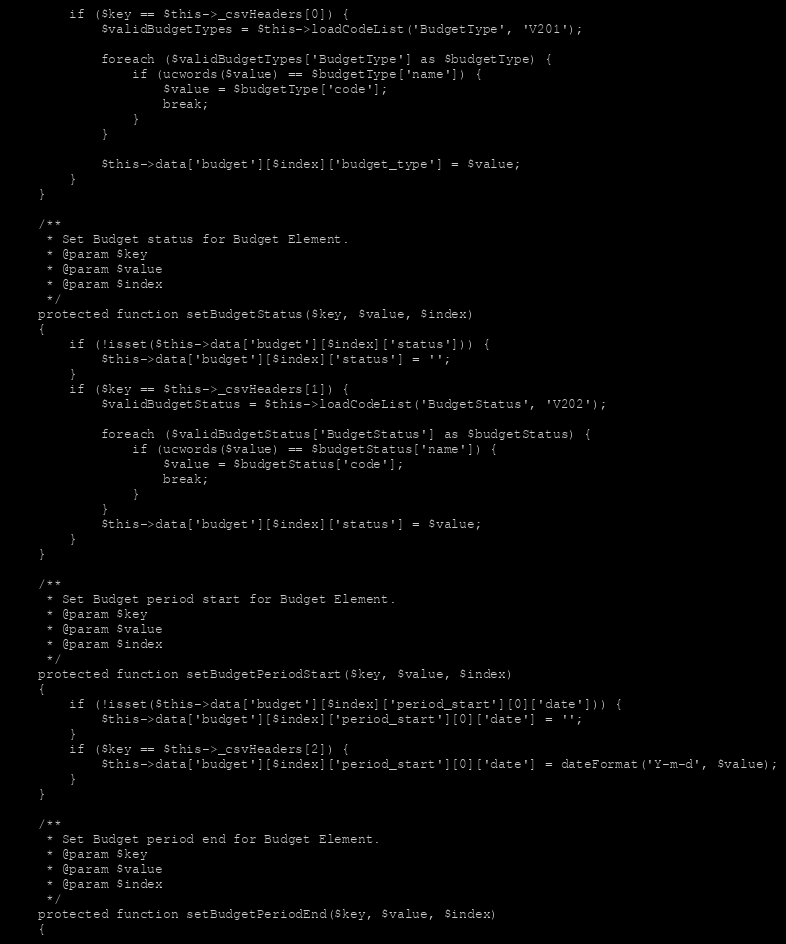Convert code to text. <code><loc_0><loc_0><loc_500><loc_500><_PHP_>        if ($key == $this->_csvHeaders[0]) {
            $validBudgetTypes = $this->loadCodeList('BudgetType', 'V201');

            foreach ($validBudgetTypes['BudgetType'] as $budgetType) {
                if (ucwords($value) == $budgetType['name']) {
                    $value = $budgetType['code'];
                    break;
                }
            }

            $this->data['budget'][$index]['budget_type'] = $value;
        }
    }

    /**
     * Set Budget status for Budget Element.
     * @param $key
     * @param $value
     * @param $index
     */
    protected function setBudgetStatus($key, $value, $index)
    {
        if (!isset($this->data['budget'][$index]['status'])) {
            $this->data['budget'][$index]['status'] = '';
        }
        if ($key == $this->_csvHeaders[1]) {
            $validBudgetStatus = $this->loadCodeList('BudgetStatus', 'V202');

            foreach ($validBudgetStatus['BudgetStatus'] as $budgetStatus) {
                if (ucwords($value) == $budgetStatus['name']) {
                    $value = $budgetStatus['code'];
                    break;
                }
            }
            $this->data['budget'][$index]['status'] = $value;
        }
    }

    /**
     * Set Budget period start for Budget Element.
     * @param $key
     * @param $value
     * @param $index
     */
    protected function setBudgetPeriodStart($key, $value, $index)
    {
        if (!isset($this->data['budget'][$index]['period_start'][0]['date'])) {
            $this->data['budget'][$index]['period_start'][0]['date'] = '';
        }
        if ($key == $this->_csvHeaders[2]) {
            $this->data['budget'][$index]['period_start'][0]['date'] = dateFormat('Y-m-d', $value);
        }
    }

    /**
     * Set Budget period end for Budget Element.
     * @param $key
     * @param $value
     * @param $index
     */
    protected function setBudgetPeriodEnd($key, $value, $index)
    {</code> 